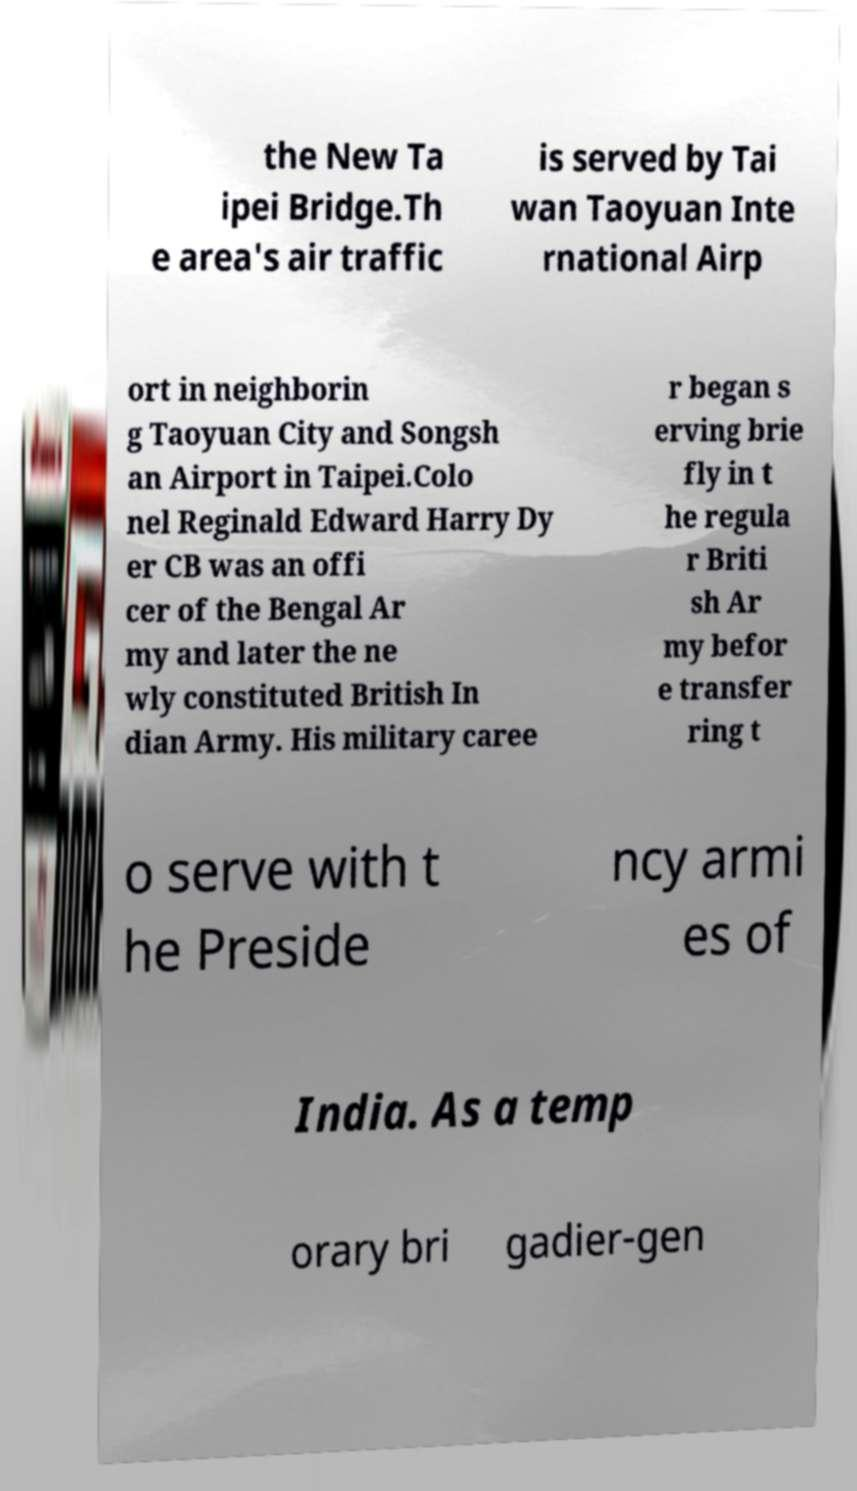Please identify and transcribe the text found in this image. the New Ta ipei Bridge.Th e area's air traffic is served by Tai wan Taoyuan Inte rnational Airp ort in neighborin g Taoyuan City and Songsh an Airport in Taipei.Colo nel Reginald Edward Harry Dy er CB was an offi cer of the Bengal Ar my and later the ne wly constituted British In dian Army. His military caree r began s erving brie fly in t he regula r Briti sh Ar my befor e transfer ring t o serve with t he Preside ncy armi es of India. As a temp orary bri gadier-gen 